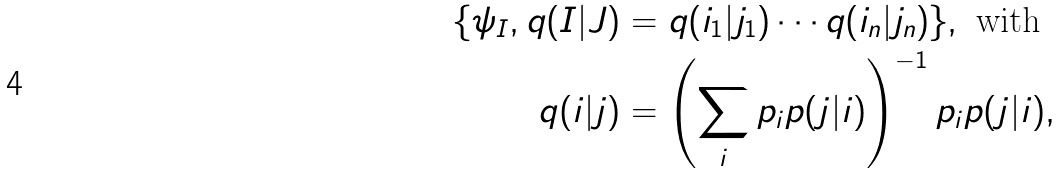<formula> <loc_0><loc_0><loc_500><loc_500>\{ \psi _ { I } , q ( I | J ) & = q ( i _ { 1 } | j _ { 1 } ) \cdots q ( i _ { n } | j _ { n } ) \} , \text { with} \\ q ( i | j ) & = \left ( \sum _ { i } p _ { i } p ( j | i ) \right ) ^ { - 1 } p _ { i } p ( j | i ) ,</formula> 